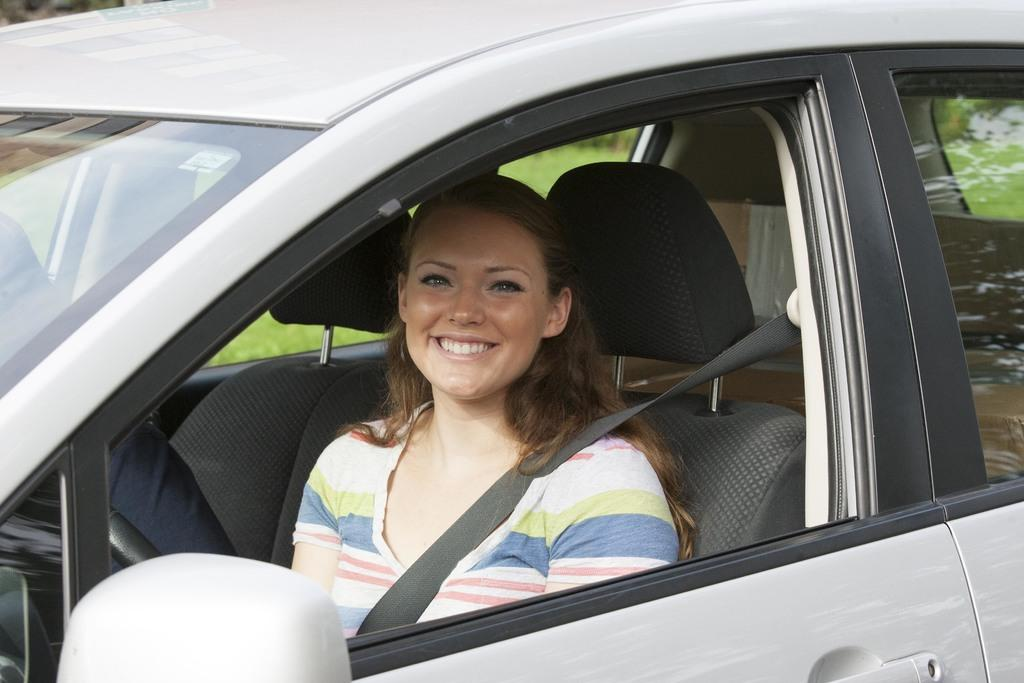Who is present in the image? There are women in the image. What are the women wearing while inside the car? The women are wearing seat belts. What is the facial expression of the women in the image? The women are smiling. Where are the women located in the image? The women are inside a car. How many people are in the car with the women? There is another person in the car with them. What can be seen through the car window? Grass is visible through the car window. What type of humor is being displayed by the health of the weather in the image? There is no humor, health, or weather mentioned in the image. The image only features women inside a car, wearing seat belts, and smiling. 